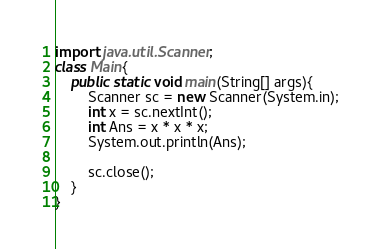Convert code to text. <code><loc_0><loc_0><loc_500><loc_500><_Java_>import java.util.Scanner;
class Main{
    public static void main(String[] args){
        Scanner sc = new Scanner(System.in);
        int x = sc.nextInt();
        int Ans = x * x * x;
        System.out.println(Ans);
        
        sc.close();     
    }
}
</code> 